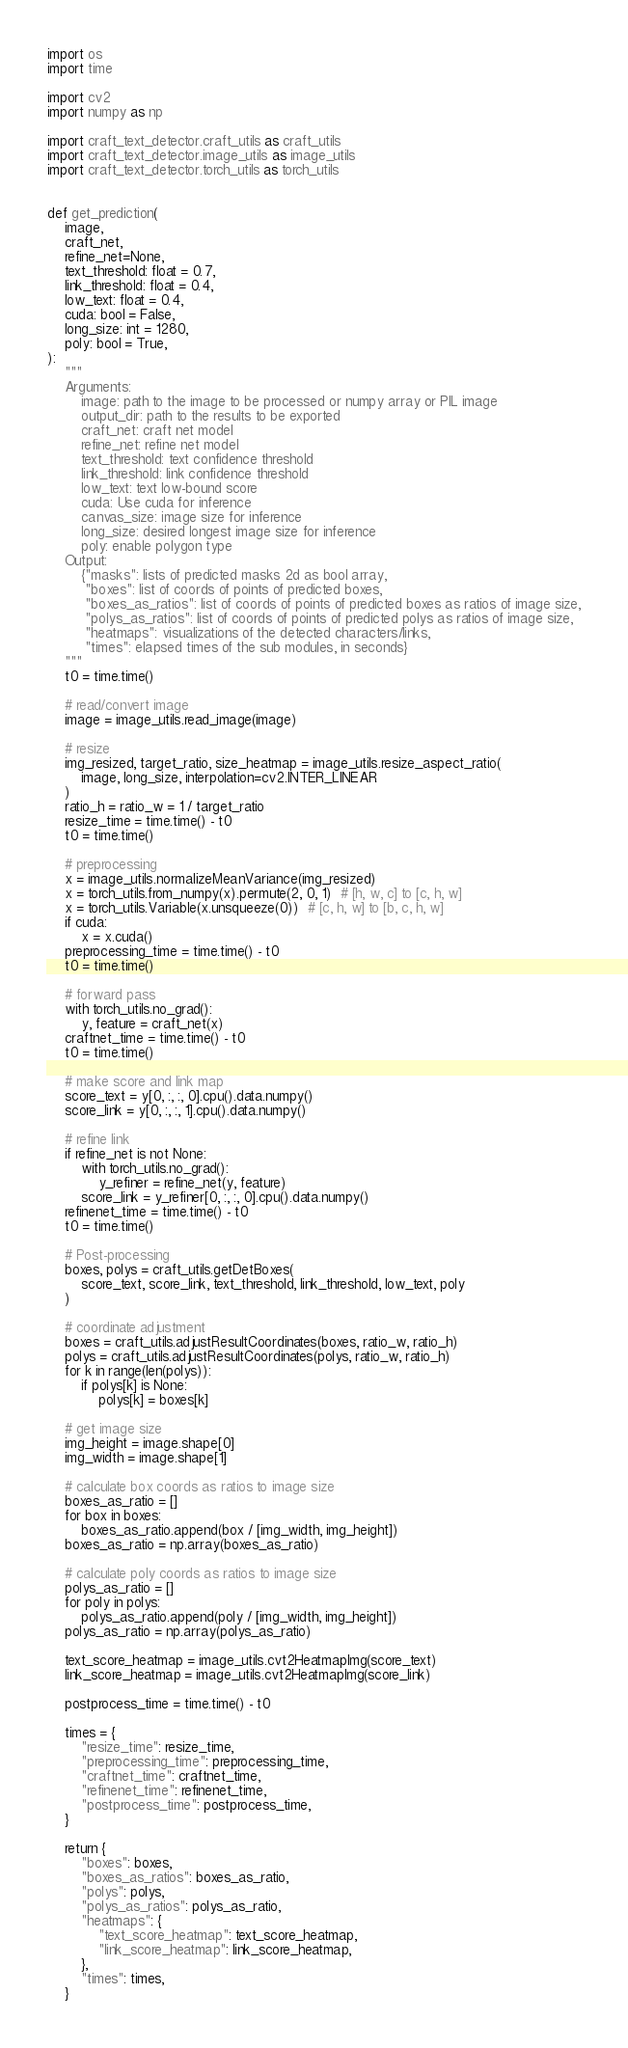Convert code to text. <code><loc_0><loc_0><loc_500><loc_500><_Python_>import os
import time

import cv2
import numpy as np

import craft_text_detector.craft_utils as craft_utils
import craft_text_detector.image_utils as image_utils
import craft_text_detector.torch_utils as torch_utils


def get_prediction(
    image,
    craft_net,
    refine_net=None,
    text_threshold: float = 0.7,
    link_threshold: float = 0.4,
    low_text: float = 0.4,
    cuda: bool = False,
    long_size: int = 1280,
    poly: bool = True,
):
    """
    Arguments:
        image: path to the image to be processed or numpy array or PIL image
        output_dir: path to the results to be exported
        craft_net: craft net model
        refine_net: refine net model
        text_threshold: text confidence threshold
        link_threshold: link confidence threshold
        low_text: text low-bound score
        cuda: Use cuda for inference
        canvas_size: image size for inference
        long_size: desired longest image size for inference
        poly: enable polygon type
    Output:
        {"masks": lists of predicted masks 2d as bool array,
         "boxes": list of coords of points of predicted boxes,
         "boxes_as_ratios": list of coords of points of predicted boxes as ratios of image size,
         "polys_as_ratios": list of coords of points of predicted polys as ratios of image size,
         "heatmaps": visualizations of the detected characters/links,
         "times": elapsed times of the sub modules, in seconds}
    """
    t0 = time.time()

    # read/convert image
    image = image_utils.read_image(image)

    # resize
    img_resized, target_ratio, size_heatmap = image_utils.resize_aspect_ratio(
        image, long_size, interpolation=cv2.INTER_LINEAR
    )
    ratio_h = ratio_w = 1 / target_ratio
    resize_time = time.time() - t0
    t0 = time.time()

    # preprocessing
    x = image_utils.normalizeMeanVariance(img_resized)
    x = torch_utils.from_numpy(x).permute(2, 0, 1)  # [h, w, c] to [c, h, w]
    x = torch_utils.Variable(x.unsqueeze(0))  # [c, h, w] to [b, c, h, w]
    if cuda:
        x = x.cuda()
    preprocessing_time = time.time() - t0
    t0 = time.time()

    # forward pass
    with torch_utils.no_grad():
        y, feature = craft_net(x)
    craftnet_time = time.time() - t0
    t0 = time.time()

    # make score and link map
    score_text = y[0, :, :, 0].cpu().data.numpy()
    score_link = y[0, :, :, 1].cpu().data.numpy()

    # refine link
    if refine_net is not None:
        with torch_utils.no_grad():
            y_refiner = refine_net(y, feature)
        score_link = y_refiner[0, :, :, 0].cpu().data.numpy()
    refinenet_time = time.time() - t0
    t0 = time.time()

    # Post-processing
    boxes, polys = craft_utils.getDetBoxes(
        score_text, score_link, text_threshold, link_threshold, low_text, poly
    )

    # coordinate adjustment
    boxes = craft_utils.adjustResultCoordinates(boxes, ratio_w, ratio_h)
    polys = craft_utils.adjustResultCoordinates(polys, ratio_w, ratio_h)
    for k in range(len(polys)):
        if polys[k] is None:
            polys[k] = boxes[k]

    # get image size
    img_height = image.shape[0]
    img_width = image.shape[1]

    # calculate box coords as ratios to image size
    boxes_as_ratio = []
    for box in boxes:
        boxes_as_ratio.append(box / [img_width, img_height])
    boxes_as_ratio = np.array(boxes_as_ratio)

    # calculate poly coords as ratios to image size
    polys_as_ratio = []
    for poly in polys:
        polys_as_ratio.append(poly / [img_width, img_height])
    polys_as_ratio = np.array(polys_as_ratio)

    text_score_heatmap = image_utils.cvt2HeatmapImg(score_text)
    link_score_heatmap = image_utils.cvt2HeatmapImg(score_link)

    postprocess_time = time.time() - t0

    times = {
        "resize_time": resize_time,
        "preprocessing_time": preprocessing_time,
        "craftnet_time": craftnet_time,
        "refinenet_time": refinenet_time,
        "postprocess_time": postprocess_time,
    }

    return {
        "boxes": boxes,
        "boxes_as_ratios": boxes_as_ratio,
        "polys": polys,
        "polys_as_ratios": polys_as_ratio,
        "heatmaps": {
            "text_score_heatmap": text_score_heatmap,
            "link_score_heatmap": link_score_heatmap,
        },
        "times": times,
    }
</code> 